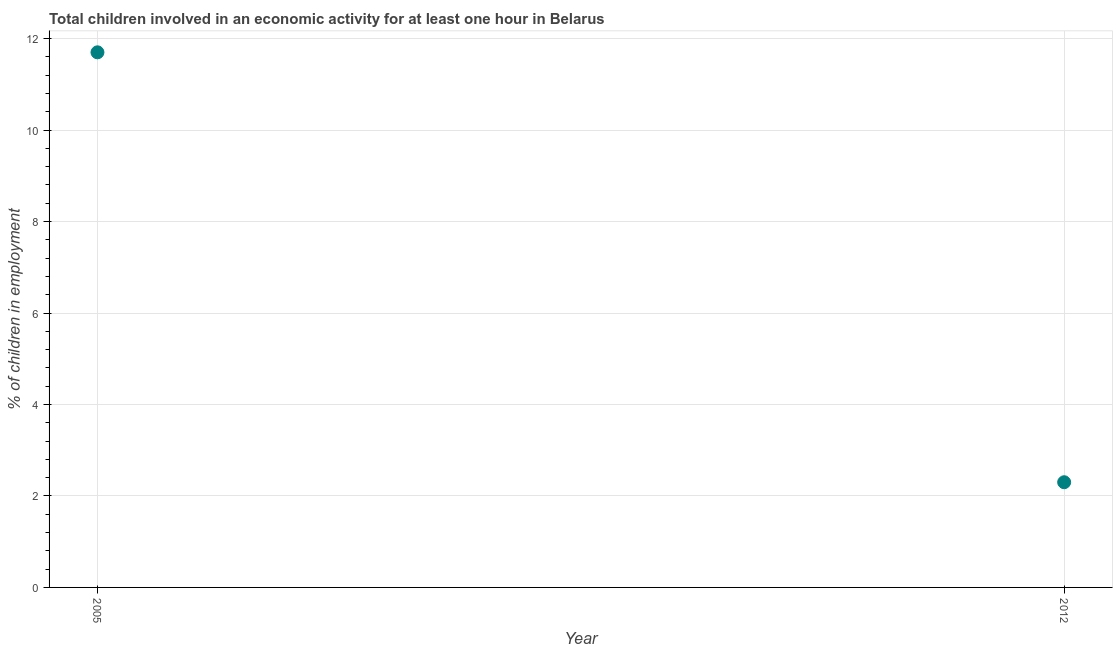What is the percentage of children in employment in 2012?
Provide a short and direct response. 2.3. Across all years, what is the maximum percentage of children in employment?
Give a very brief answer. 11.7. Across all years, what is the minimum percentage of children in employment?
Your response must be concise. 2.3. In which year was the percentage of children in employment minimum?
Your response must be concise. 2012. What is the difference between the percentage of children in employment in 2005 and 2012?
Provide a succinct answer. 9.4. What is the average percentage of children in employment per year?
Provide a succinct answer. 7. What is the median percentage of children in employment?
Offer a very short reply. 7. Do a majority of the years between 2012 and 2005 (inclusive) have percentage of children in employment greater than 8 %?
Keep it short and to the point. No. What is the ratio of the percentage of children in employment in 2005 to that in 2012?
Make the answer very short. 5.09. Is the percentage of children in employment in 2005 less than that in 2012?
Your answer should be very brief. No. In how many years, is the percentage of children in employment greater than the average percentage of children in employment taken over all years?
Your response must be concise. 1. Does the percentage of children in employment monotonically increase over the years?
Provide a succinct answer. No. How many dotlines are there?
Provide a succinct answer. 1. How many years are there in the graph?
Make the answer very short. 2. What is the difference between two consecutive major ticks on the Y-axis?
Give a very brief answer. 2. Are the values on the major ticks of Y-axis written in scientific E-notation?
Keep it short and to the point. No. What is the title of the graph?
Your answer should be compact. Total children involved in an economic activity for at least one hour in Belarus. What is the label or title of the X-axis?
Ensure brevity in your answer.  Year. What is the label or title of the Y-axis?
Your answer should be very brief. % of children in employment. What is the difference between the % of children in employment in 2005 and 2012?
Provide a succinct answer. 9.4. What is the ratio of the % of children in employment in 2005 to that in 2012?
Give a very brief answer. 5.09. 